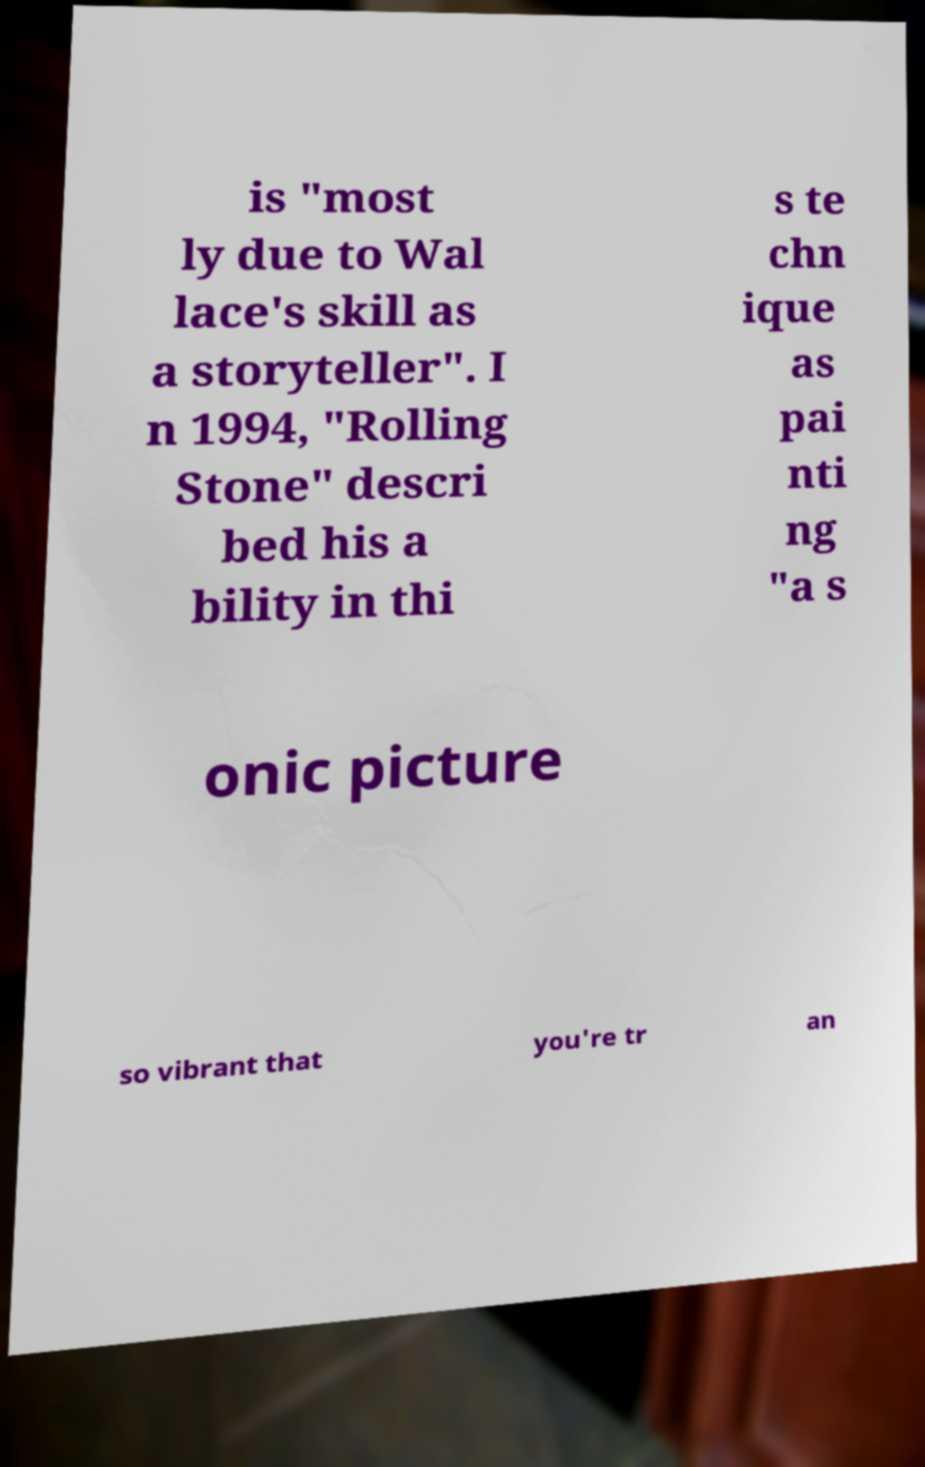For documentation purposes, I need the text within this image transcribed. Could you provide that? is "most ly due to Wal lace's skill as a storyteller". I n 1994, "Rolling Stone" descri bed his a bility in thi s te chn ique as pai nti ng "a s onic picture so vibrant that you're tr an 